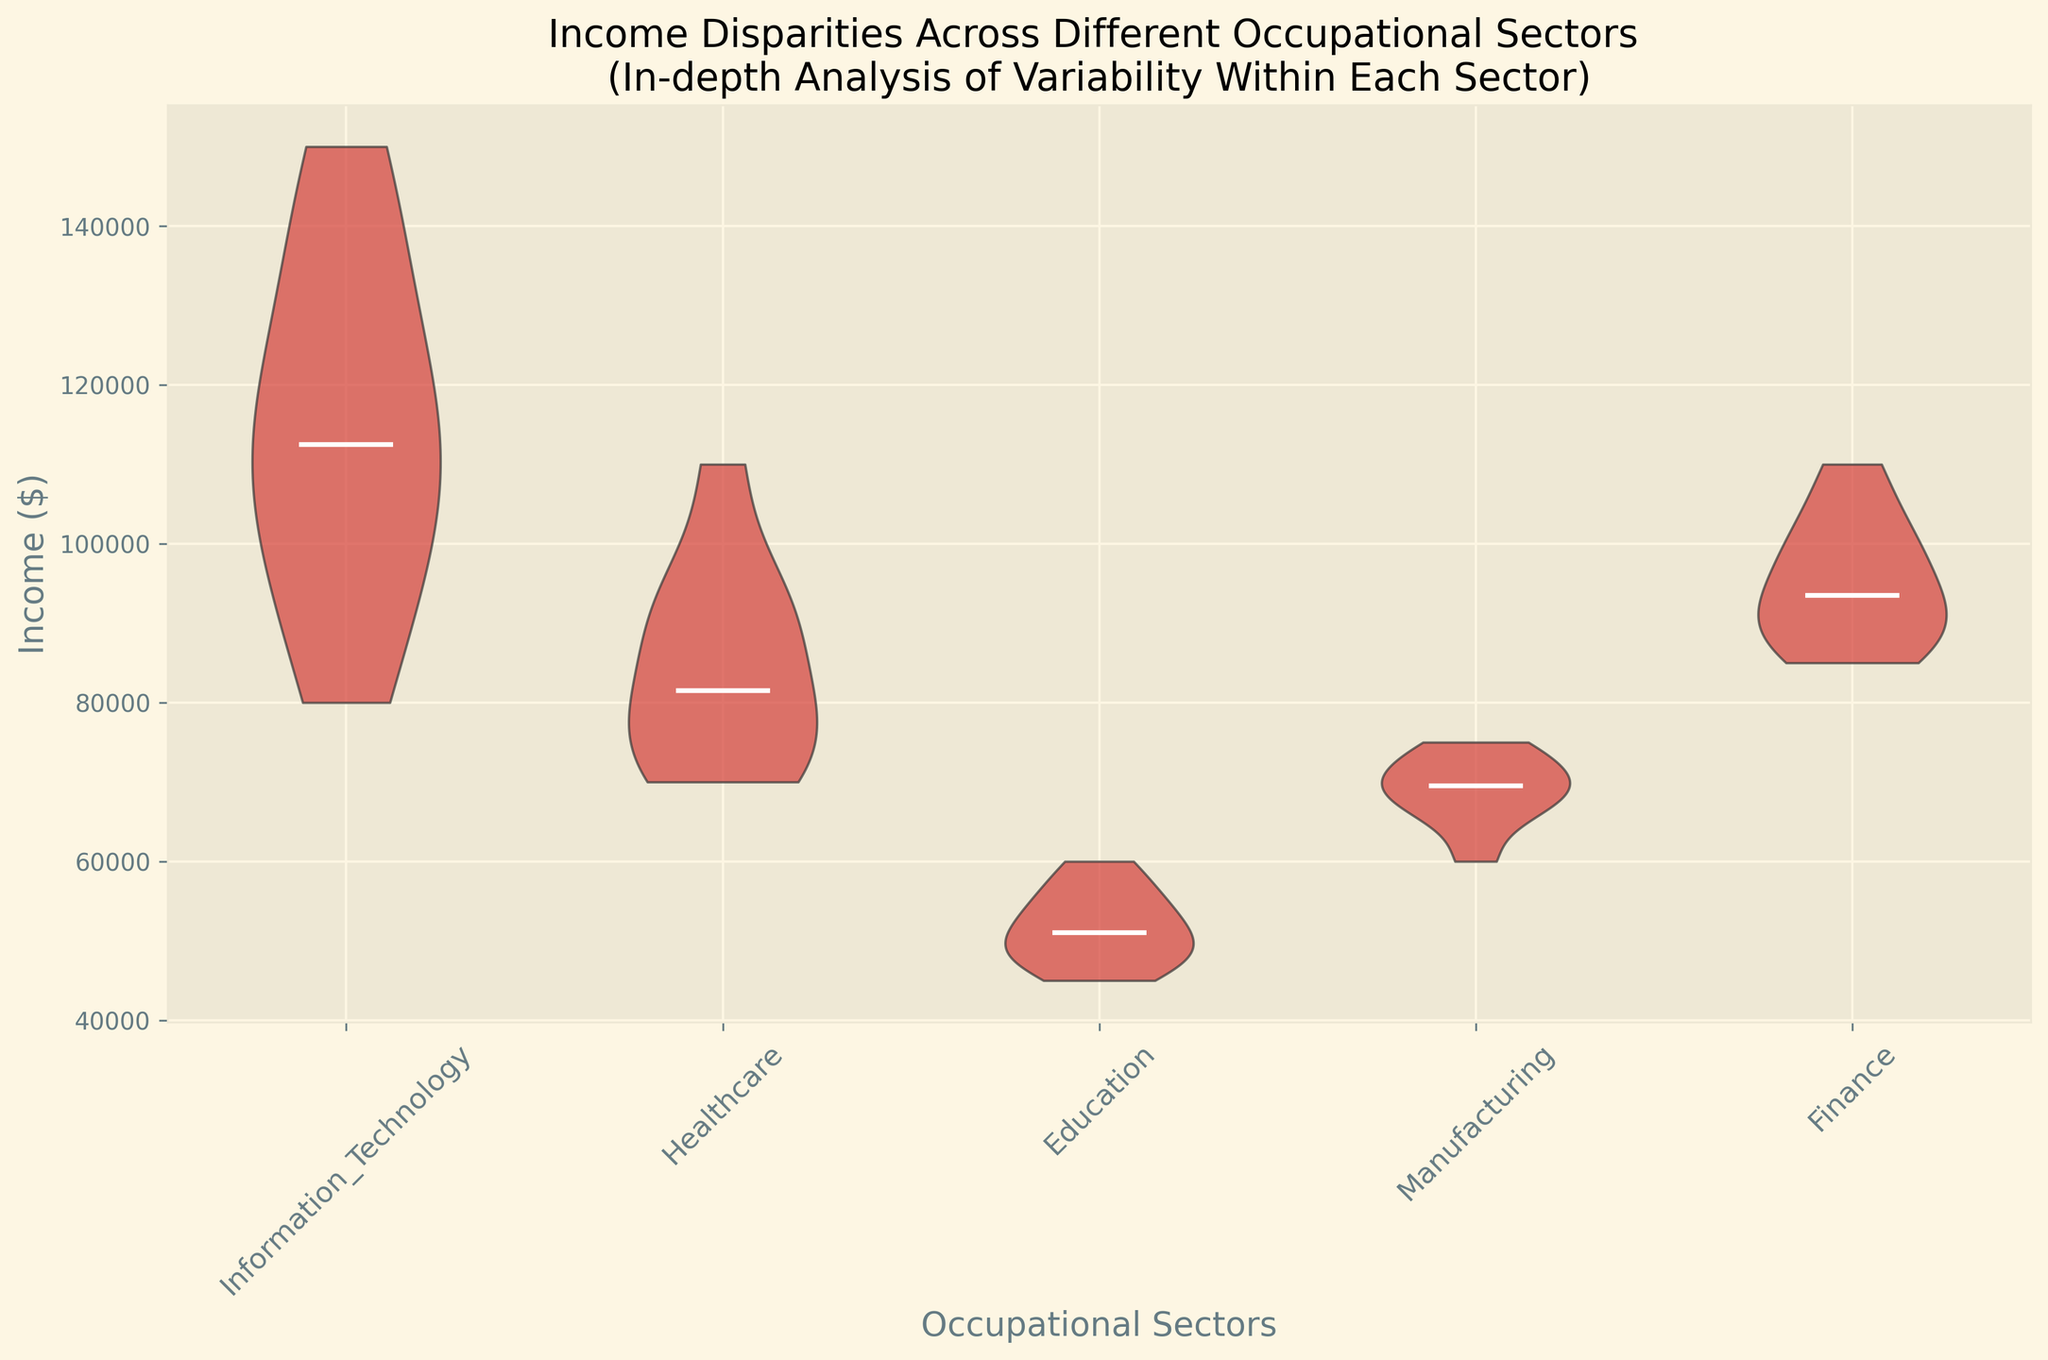What is the median income in the Healthcare sector? The median income is the value that divides the income data in the Healthcare sector into two equal halves, visually represented by the white line within the violin plot for the Healthcare sector. By inspecting the white line's position within the Healthcare violin, one can determine the median.
Answer: 85,000 Which occupational sector exhibits the highest variability in income? The variability in income within each sector is represented by the width and spread of the violin plots. The sector with a wider and more spread out violin plot indicates higher variability. By comparing all sectors, it appears that Information Technology has the widest spread.
Answer: Information Technology How does the income range of the Education sector compare to the Finance sector? By comparing the spans of the violin plots vertically, one can observe the range of incomes within each sector. The Education sector has a narrower vertical span compared to the Finance sector, indicating a smaller income range.
Answer: The income range in Education is smaller than in Finance Which sector has the lowest median income? To determine the sector with the lowest median income, inspect the position of the white median lines in each violin plot relative to each other. The lowest median line is in the Education sector.
Answer: Education What is the visual color representation utilized for the median lines in the plot? The visual attributes of the violin plot include a white line representing the median income within each sector. It is useful to clarify that the white lines denote the medians.
Answer: White Are there sectors with overlapping income ranges, and if so, which ones? By examining the vertical spans of the violin plots, sectors with overlapping ranges can be identified. For example, the income ranges of Manufacturing and Healthcare overlap significantly.
Answer: Manufacturing and Healthcare What can you infer about the income distribution in Information Technology compared to Education? The Information Technology sector shows a more extended and wider distribution compared to the Education sector, indicating more variability and higher income values. Education's distribution is narrower and more compact.
Answer: IT has higher variability and incomes compared to Education How does the second quartile income compare between the Manufacturing and Healthcare sectors? The second quartile (median) income can be identified by the white median lines in the violin plots. The median line in the Manufacturing sector is slightly above the line in Healthcare, indicating a higher second quartile income for Manufacturing.
Answer: Manufacturing is higher than Healthcare Which sector shows the narrowest income distribution? A narrow distribution is identified by a densely packed, slimmer violin plot. By visually comparing all plots, the Education sector appears to have the narrowest distribution.
Answer: Education 